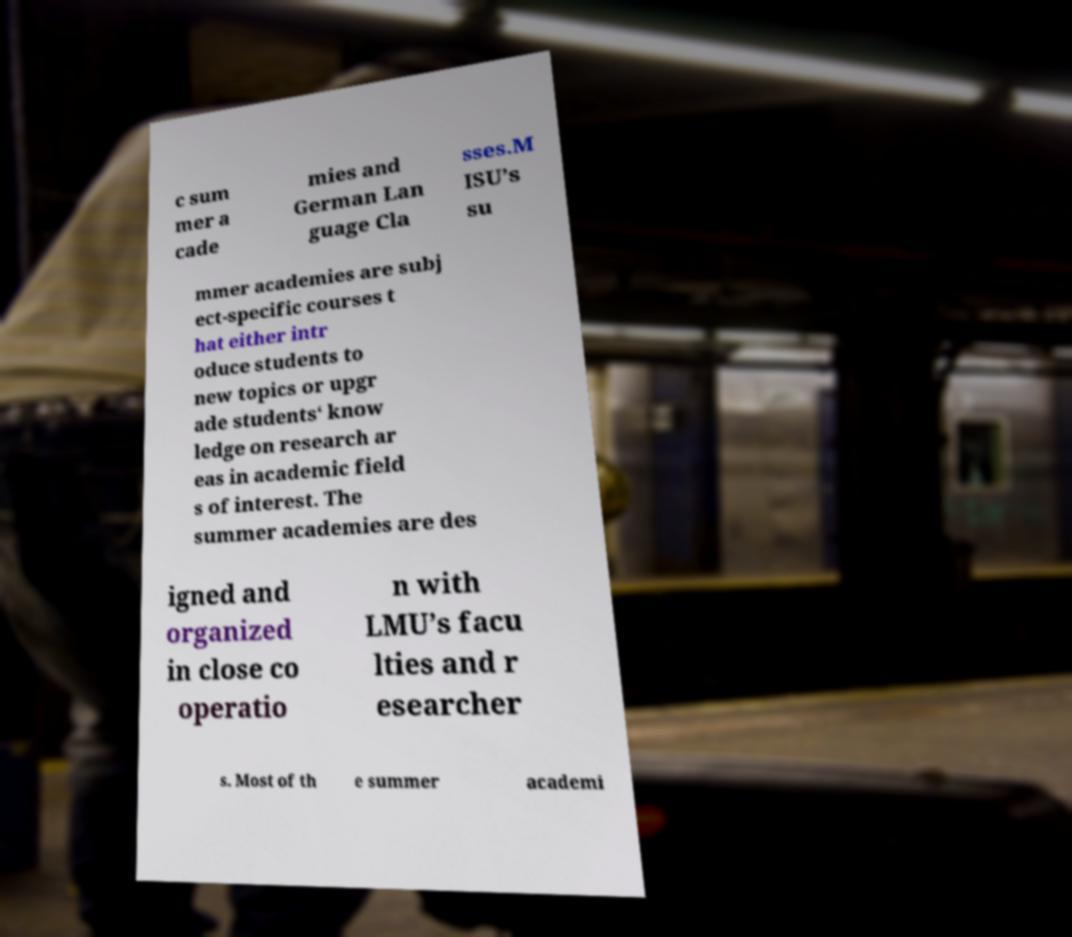What messages or text are displayed in this image? I need them in a readable, typed format. c sum mer a cade mies and German Lan guage Cla sses.M ISU’s su mmer academies are subj ect-specific courses t hat either intr oduce students to new topics or upgr ade students‘ know ledge on research ar eas in academic field s of interest. The summer academies are des igned and organized in close co operatio n with LMU’s facu lties and r esearcher s. Most of th e summer academi 